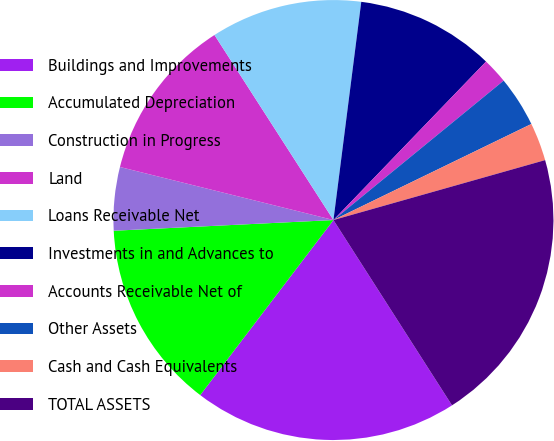Convert chart. <chart><loc_0><loc_0><loc_500><loc_500><pie_chart><fcel>Buildings and Improvements<fcel>Accumulated Depreciation<fcel>Construction in Progress<fcel>Land<fcel>Loans Receivable Net<fcel>Investments in and Advances to<fcel>Accounts Receivable Net of<fcel>Other Assets<fcel>Cash and Cash Equivalents<fcel>TOTAL ASSETS<nl><fcel>19.41%<fcel>13.87%<fcel>4.65%<fcel>12.03%<fcel>11.11%<fcel>10.18%<fcel>1.88%<fcel>3.73%<fcel>2.8%<fcel>20.33%<nl></chart> 